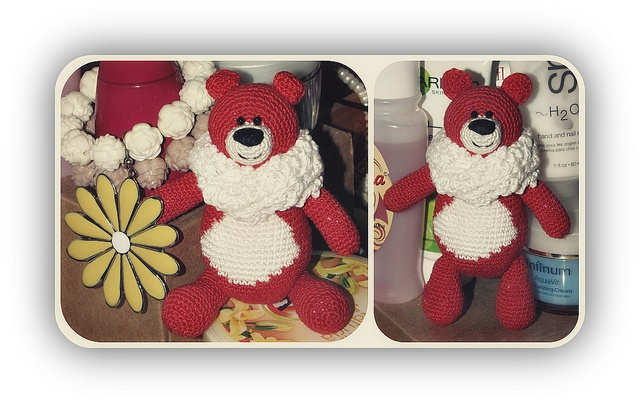Describe the objects in this image and their specific colors. I can see teddy bear in white, brown, beige, maroon, and lightgray tones and teddy bear in white, maroon, brown, beige, and lightgray tones in this image. 